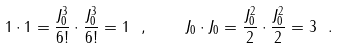<formula> <loc_0><loc_0><loc_500><loc_500>1 \cdot 1 = \frac { J _ { 0 } ^ { 3 } } { 6 ! } \cdot \frac { J _ { 0 } ^ { 3 } } { 6 ! } = 1 \ , \quad J _ { 0 } \cdot J _ { 0 } = \frac { J _ { 0 } ^ { 2 } } 2 \cdot \frac { J _ { 0 } ^ { 2 } } 2 = 3 \ .</formula> 